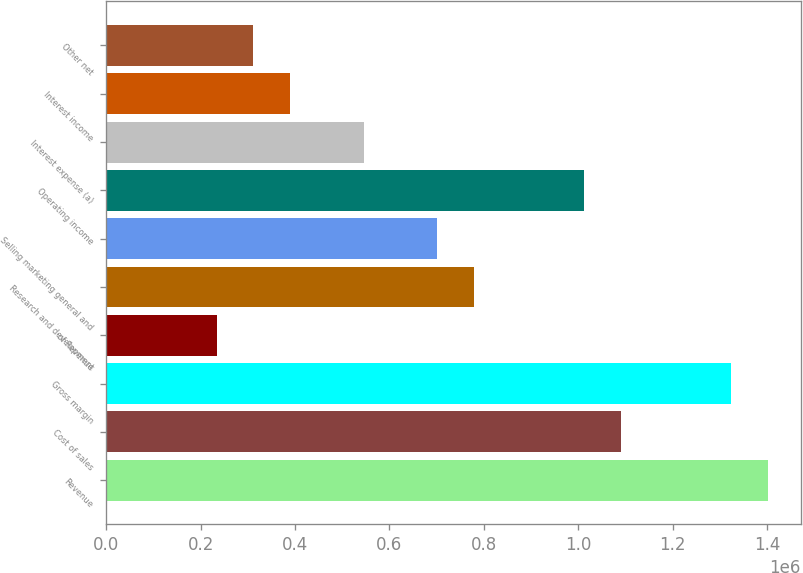<chart> <loc_0><loc_0><loc_500><loc_500><bar_chart><fcel>Revenue<fcel>Cost of sales<fcel>Gross margin<fcel>of Revenue<fcel>Research and development<fcel>Selling marketing general and<fcel>Operating income<fcel>Interest expense (a)<fcel>Interest income<fcel>Other net<nl><fcel>1.40178e+06<fcel>1.09027e+06<fcel>1.3239e+06<fcel>233630<fcel>778766<fcel>700889<fcel>1.0124e+06<fcel>545136<fcel>389383<fcel>311507<nl></chart> 